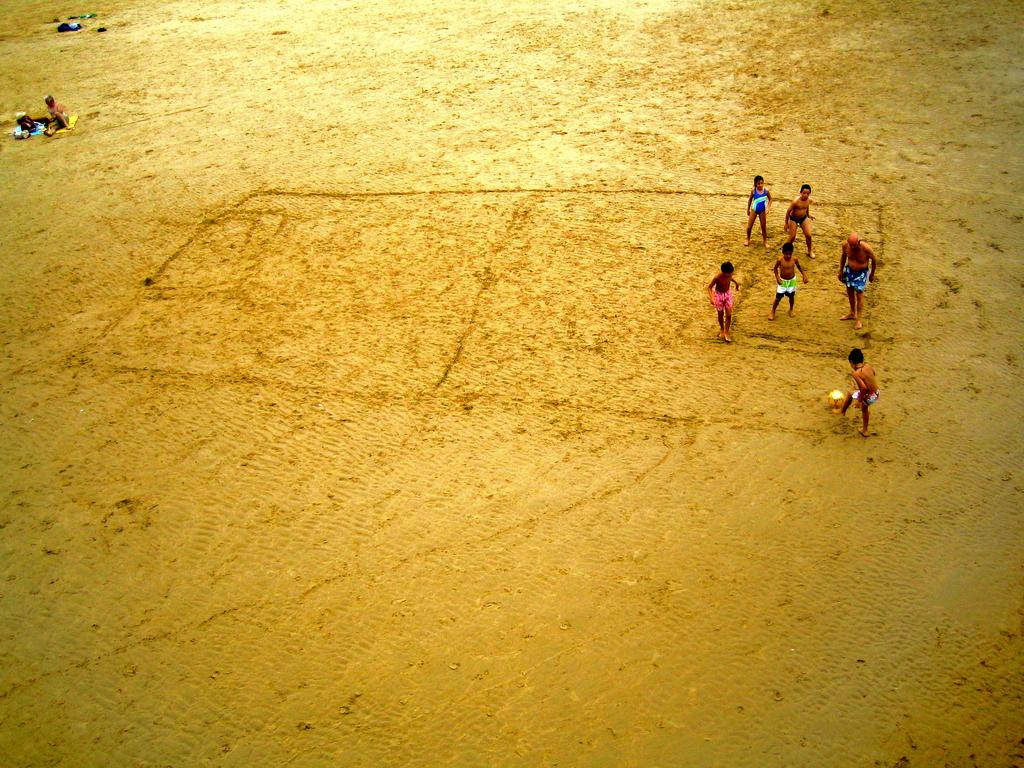How many individuals are present in the image? There is a group of people in the image. What is the position of the people in the image? The people are on the ground. What type of writing can be seen on the ground in the image? There is no writing visible on the ground in the image. 